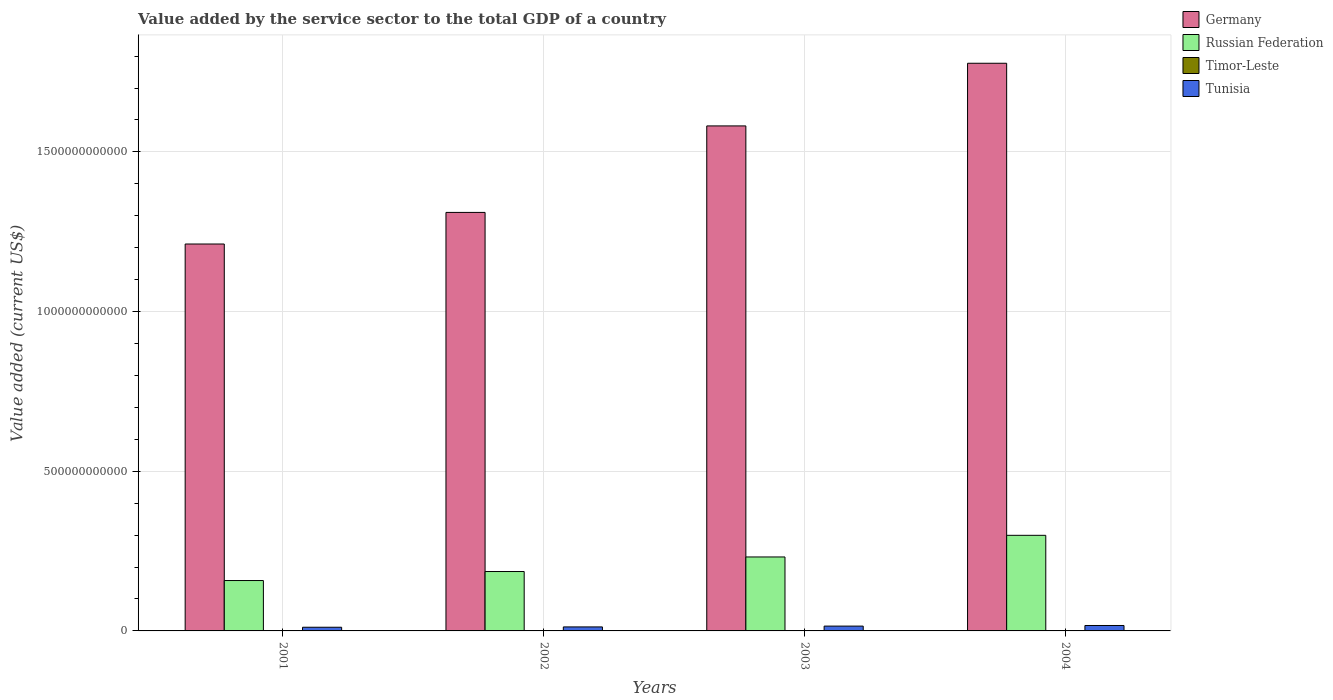How many different coloured bars are there?
Make the answer very short. 4. How many groups of bars are there?
Give a very brief answer. 4. Are the number of bars per tick equal to the number of legend labels?
Provide a succinct answer. Yes. How many bars are there on the 2nd tick from the right?
Make the answer very short. 4. In how many cases, is the number of bars for a given year not equal to the number of legend labels?
Provide a short and direct response. 0. What is the value added by the service sector to the total GDP in Russian Federation in 2001?
Provide a short and direct response. 1.58e+11. Across all years, what is the maximum value added by the service sector to the total GDP in Timor-Leste?
Keep it short and to the point. 2.78e+08. Across all years, what is the minimum value added by the service sector to the total GDP in Germany?
Offer a terse response. 1.21e+12. In which year was the value added by the service sector to the total GDP in Tunisia maximum?
Your answer should be compact. 2004. In which year was the value added by the service sector to the total GDP in Tunisia minimum?
Provide a succinct answer. 2001. What is the total value added by the service sector to the total GDP in Timor-Leste in the graph?
Offer a very short reply. 1.08e+09. What is the difference between the value added by the service sector to the total GDP in Tunisia in 2001 and that in 2002?
Provide a short and direct response. -9.86e+08. What is the difference between the value added by the service sector to the total GDP in Germany in 2003 and the value added by the service sector to the total GDP in Tunisia in 2004?
Your response must be concise. 1.56e+12. What is the average value added by the service sector to the total GDP in Tunisia per year?
Keep it short and to the point. 1.40e+1. In the year 2001, what is the difference between the value added by the service sector to the total GDP in Russian Federation and value added by the service sector to the total GDP in Timor-Leste?
Give a very brief answer. 1.58e+11. In how many years, is the value added by the service sector to the total GDP in Tunisia greater than 1000000000000 US$?
Make the answer very short. 0. What is the ratio of the value added by the service sector to the total GDP in Timor-Leste in 2003 to that in 2004?
Give a very brief answer. 0.97. What is the difference between the highest and the second highest value added by the service sector to the total GDP in Tunisia?
Ensure brevity in your answer.  1.94e+09. What is the difference between the highest and the lowest value added by the service sector to the total GDP in Tunisia?
Ensure brevity in your answer.  5.48e+09. In how many years, is the value added by the service sector to the total GDP in Timor-Leste greater than the average value added by the service sector to the total GDP in Timor-Leste taken over all years?
Ensure brevity in your answer.  2. Is the sum of the value added by the service sector to the total GDP in Russian Federation in 2002 and 2003 greater than the maximum value added by the service sector to the total GDP in Timor-Leste across all years?
Provide a short and direct response. Yes. What does the 4th bar from the left in 2004 represents?
Offer a very short reply. Tunisia. What does the 1st bar from the right in 2002 represents?
Offer a very short reply. Tunisia. How many bars are there?
Provide a short and direct response. 16. How many years are there in the graph?
Provide a succinct answer. 4. What is the difference between two consecutive major ticks on the Y-axis?
Give a very brief answer. 5.00e+11. Are the values on the major ticks of Y-axis written in scientific E-notation?
Keep it short and to the point. No. What is the title of the graph?
Your response must be concise. Value added by the service sector to the total GDP of a country. What is the label or title of the Y-axis?
Give a very brief answer. Value added (current US$). What is the Value added (current US$) in Germany in 2001?
Offer a terse response. 1.21e+12. What is the Value added (current US$) of Russian Federation in 2001?
Provide a short and direct response. 1.58e+11. What is the Value added (current US$) of Timor-Leste in 2001?
Provide a short and direct response. 2.78e+08. What is the Value added (current US$) of Tunisia in 2001?
Keep it short and to the point. 1.15e+1. What is the Value added (current US$) of Germany in 2002?
Keep it short and to the point. 1.31e+12. What is the Value added (current US$) of Russian Federation in 2002?
Ensure brevity in your answer.  1.86e+11. What is the Value added (current US$) of Timor-Leste in 2002?
Give a very brief answer. 2.60e+08. What is the Value added (current US$) of Tunisia in 2002?
Offer a very short reply. 1.25e+1. What is the Value added (current US$) of Germany in 2003?
Offer a terse response. 1.58e+12. What is the Value added (current US$) of Russian Federation in 2003?
Make the answer very short. 2.32e+11. What is the Value added (current US$) of Timor-Leste in 2003?
Provide a succinct answer. 2.65e+08. What is the Value added (current US$) of Tunisia in 2003?
Your response must be concise. 1.51e+1. What is the Value added (current US$) in Germany in 2004?
Make the answer very short. 1.78e+12. What is the Value added (current US$) of Russian Federation in 2004?
Offer a terse response. 2.99e+11. What is the Value added (current US$) in Timor-Leste in 2004?
Your answer should be compact. 2.72e+08. What is the Value added (current US$) in Tunisia in 2004?
Ensure brevity in your answer.  1.70e+1. Across all years, what is the maximum Value added (current US$) of Germany?
Provide a short and direct response. 1.78e+12. Across all years, what is the maximum Value added (current US$) in Russian Federation?
Your answer should be compact. 2.99e+11. Across all years, what is the maximum Value added (current US$) of Timor-Leste?
Your answer should be compact. 2.78e+08. Across all years, what is the maximum Value added (current US$) in Tunisia?
Provide a short and direct response. 1.70e+1. Across all years, what is the minimum Value added (current US$) in Germany?
Your answer should be very brief. 1.21e+12. Across all years, what is the minimum Value added (current US$) of Russian Federation?
Keep it short and to the point. 1.58e+11. Across all years, what is the minimum Value added (current US$) of Timor-Leste?
Provide a short and direct response. 2.60e+08. Across all years, what is the minimum Value added (current US$) of Tunisia?
Your response must be concise. 1.15e+1. What is the total Value added (current US$) in Germany in the graph?
Your response must be concise. 5.88e+12. What is the total Value added (current US$) in Russian Federation in the graph?
Your answer should be very brief. 8.75e+11. What is the total Value added (current US$) of Timor-Leste in the graph?
Ensure brevity in your answer.  1.08e+09. What is the total Value added (current US$) in Tunisia in the graph?
Your answer should be very brief. 5.62e+1. What is the difference between the Value added (current US$) of Germany in 2001 and that in 2002?
Provide a succinct answer. -9.89e+1. What is the difference between the Value added (current US$) in Russian Federation in 2001 and that in 2002?
Provide a short and direct response. -2.82e+1. What is the difference between the Value added (current US$) of Timor-Leste in 2001 and that in 2002?
Provide a succinct answer. 1.80e+07. What is the difference between the Value added (current US$) of Tunisia in 2001 and that in 2002?
Make the answer very short. -9.86e+08. What is the difference between the Value added (current US$) in Germany in 2001 and that in 2003?
Offer a terse response. -3.70e+11. What is the difference between the Value added (current US$) in Russian Federation in 2001 and that in 2003?
Offer a terse response. -7.38e+1. What is the difference between the Value added (current US$) of Timor-Leste in 2001 and that in 2003?
Give a very brief answer. 1.30e+07. What is the difference between the Value added (current US$) in Tunisia in 2001 and that in 2003?
Your response must be concise. -3.55e+09. What is the difference between the Value added (current US$) in Germany in 2001 and that in 2004?
Your answer should be compact. -5.66e+11. What is the difference between the Value added (current US$) in Russian Federation in 2001 and that in 2004?
Offer a very short reply. -1.42e+11. What is the difference between the Value added (current US$) in Timor-Leste in 2001 and that in 2004?
Make the answer very short. 6.00e+06. What is the difference between the Value added (current US$) of Tunisia in 2001 and that in 2004?
Your answer should be very brief. -5.48e+09. What is the difference between the Value added (current US$) of Germany in 2002 and that in 2003?
Give a very brief answer. -2.71e+11. What is the difference between the Value added (current US$) in Russian Federation in 2002 and that in 2003?
Your answer should be very brief. -4.56e+1. What is the difference between the Value added (current US$) of Timor-Leste in 2002 and that in 2003?
Keep it short and to the point. -5.00e+06. What is the difference between the Value added (current US$) of Tunisia in 2002 and that in 2003?
Make the answer very short. -2.56e+09. What is the difference between the Value added (current US$) of Germany in 2002 and that in 2004?
Provide a succinct answer. -4.67e+11. What is the difference between the Value added (current US$) of Russian Federation in 2002 and that in 2004?
Offer a very short reply. -1.13e+11. What is the difference between the Value added (current US$) in Timor-Leste in 2002 and that in 2004?
Your answer should be very brief. -1.20e+07. What is the difference between the Value added (current US$) in Tunisia in 2002 and that in 2004?
Give a very brief answer. -4.50e+09. What is the difference between the Value added (current US$) in Germany in 2003 and that in 2004?
Keep it short and to the point. -1.96e+11. What is the difference between the Value added (current US$) of Russian Federation in 2003 and that in 2004?
Your answer should be very brief. -6.78e+1. What is the difference between the Value added (current US$) in Timor-Leste in 2003 and that in 2004?
Offer a terse response. -7.00e+06. What is the difference between the Value added (current US$) in Tunisia in 2003 and that in 2004?
Ensure brevity in your answer.  -1.94e+09. What is the difference between the Value added (current US$) of Germany in 2001 and the Value added (current US$) of Russian Federation in 2002?
Provide a short and direct response. 1.03e+12. What is the difference between the Value added (current US$) in Germany in 2001 and the Value added (current US$) in Timor-Leste in 2002?
Ensure brevity in your answer.  1.21e+12. What is the difference between the Value added (current US$) in Germany in 2001 and the Value added (current US$) in Tunisia in 2002?
Offer a very short reply. 1.20e+12. What is the difference between the Value added (current US$) of Russian Federation in 2001 and the Value added (current US$) of Timor-Leste in 2002?
Make the answer very short. 1.58e+11. What is the difference between the Value added (current US$) of Russian Federation in 2001 and the Value added (current US$) of Tunisia in 2002?
Offer a terse response. 1.45e+11. What is the difference between the Value added (current US$) in Timor-Leste in 2001 and the Value added (current US$) in Tunisia in 2002?
Your answer should be very brief. -1.22e+1. What is the difference between the Value added (current US$) of Germany in 2001 and the Value added (current US$) of Russian Federation in 2003?
Offer a terse response. 9.80e+11. What is the difference between the Value added (current US$) in Germany in 2001 and the Value added (current US$) in Timor-Leste in 2003?
Your response must be concise. 1.21e+12. What is the difference between the Value added (current US$) of Germany in 2001 and the Value added (current US$) of Tunisia in 2003?
Your answer should be compact. 1.20e+12. What is the difference between the Value added (current US$) in Russian Federation in 2001 and the Value added (current US$) in Timor-Leste in 2003?
Your response must be concise. 1.58e+11. What is the difference between the Value added (current US$) in Russian Federation in 2001 and the Value added (current US$) in Tunisia in 2003?
Provide a succinct answer. 1.43e+11. What is the difference between the Value added (current US$) of Timor-Leste in 2001 and the Value added (current US$) of Tunisia in 2003?
Offer a very short reply. -1.48e+1. What is the difference between the Value added (current US$) in Germany in 2001 and the Value added (current US$) in Russian Federation in 2004?
Give a very brief answer. 9.12e+11. What is the difference between the Value added (current US$) in Germany in 2001 and the Value added (current US$) in Timor-Leste in 2004?
Your answer should be very brief. 1.21e+12. What is the difference between the Value added (current US$) in Germany in 2001 and the Value added (current US$) in Tunisia in 2004?
Offer a very short reply. 1.19e+12. What is the difference between the Value added (current US$) in Russian Federation in 2001 and the Value added (current US$) in Timor-Leste in 2004?
Give a very brief answer. 1.58e+11. What is the difference between the Value added (current US$) in Russian Federation in 2001 and the Value added (current US$) in Tunisia in 2004?
Make the answer very short. 1.41e+11. What is the difference between the Value added (current US$) of Timor-Leste in 2001 and the Value added (current US$) of Tunisia in 2004?
Your answer should be compact. -1.67e+1. What is the difference between the Value added (current US$) in Germany in 2002 and the Value added (current US$) in Russian Federation in 2003?
Your answer should be compact. 1.08e+12. What is the difference between the Value added (current US$) of Germany in 2002 and the Value added (current US$) of Timor-Leste in 2003?
Your response must be concise. 1.31e+12. What is the difference between the Value added (current US$) of Germany in 2002 and the Value added (current US$) of Tunisia in 2003?
Offer a very short reply. 1.30e+12. What is the difference between the Value added (current US$) of Russian Federation in 2002 and the Value added (current US$) of Timor-Leste in 2003?
Give a very brief answer. 1.86e+11. What is the difference between the Value added (current US$) of Russian Federation in 2002 and the Value added (current US$) of Tunisia in 2003?
Offer a terse response. 1.71e+11. What is the difference between the Value added (current US$) of Timor-Leste in 2002 and the Value added (current US$) of Tunisia in 2003?
Offer a very short reply. -1.48e+1. What is the difference between the Value added (current US$) in Germany in 2002 and the Value added (current US$) in Russian Federation in 2004?
Offer a very short reply. 1.01e+12. What is the difference between the Value added (current US$) in Germany in 2002 and the Value added (current US$) in Timor-Leste in 2004?
Offer a very short reply. 1.31e+12. What is the difference between the Value added (current US$) in Germany in 2002 and the Value added (current US$) in Tunisia in 2004?
Offer a very short reply. 1.29e+12. What is the difference between the Value added (current US$) in Russian Federation in 2002 and the Value added (current US$) in Timor-Leste in 2004?
Keep it short and to the point. 1.86e+11. What is the difference between the Value added (current US$) in Russian Federation in 2002 and the Value added (current US$) in Tunisia in 2004?
Ensure brevity in your answer.  1.69e+11. What is the difference between the Value added (current US$) of Timor-Leste in 2002 and the Value added (current US$) of Tunisia in 2004?
Provide a short and direct response. -1.68e+1. What is the difference between the Value added (current US$) of Germany in 2003 and the Value added (current US$) of Russian Federation in 2004?
Ensure brevity in your answer.  1.28e+12. What is the difference between the Value added (current US$) in Germany in 2003 and the Value added (current US$) in Timor-Leste in 2004?
Your response must be concise. 1.58e+12. What is the difference between the Value added (current US$) of Germany in 2003 and the Value added (current US$) of Tunisia in 2004?
Offer a very short reply. 1.56e+12. What is the difference between the Value added (current US$) in Russian Federation in 2003 and the Value added (current US$) in Timor-Leste in 2004?
Offer a terse response. 2.31e+11. What is the difference between the Value added (current US$) of Russian Federation in 2003 and the Value added (current US$) of Tunisia in 2004?
Provide a succinct answer. 2.15e+11. What is the difference between the Value added (current US$) of Timor-Leste in 2003 and the Value added (current US$) of Tunisia in 2004?
Offer a terse response. -1.68e+1. What is the average Value added (current US$) of Germany per year?
Offer a very short reply. 1.47e+12. What is the average Value added (current US$) of Russian Federation per year?
Your answer should be compact. 2.19e+11. What is the average Value added (current US$) in Timor-Leste per year?
Offer a very short reply. 2.69e+08. What is the average Value added (current US$) of Tunisia per year?
Your answer should be compact. 1.40e+1. In the year 2001, what is the difference between the Value added (current US$) in Germany and Value added (current US$) in Russian Federation?
Make the answer very short. 1.05e+12. In the year 2001, what is the difference between the Value added (current US$) in Germany and Value added (current US$) in Timor-Leste?
Make the answer very short. 1.21e+12. In the year 2001, what is the difference between the Value added (current US$) in Germany and Value added (current US$) in Tunisia?
Your answer should be very brief. 1.20e+12. In the year 2001, what is the difference between the Value added (current US$) of Russian Federation and Value added (current US$) of Timor-Leste?
Give a very brief answer. 1.58e+11. In the year 2001, what is the difference between the Value added (current US$) in Russian Federation and Value added (current US$) in Tunisia?
Offer a very short reply. 1.46e+11. In the year 2001, what is the difference between the Value added (current US$) in Timor-Leste and Value added (current US$) in Tunisia?
Offer a terse response. -1.13e+1. In the year 2002, what is the difference between the Value added (current US$) in Germany and Value added (current US$) in Russian Federation?
Make the answer very short. 1.12e+12. In the year 2002, what is the difference between the Value added (current US$) in Germany and Value added (current US$) in Timor-Leste?
Give a very brief answer. 1.31e+12. In the year 2002, what is the difference between the Value added (current US$) of Germany and Value added (current US$) of Tunisia?
Make the answer very short. 1.30e+12. In the year 2002, what is the difference between the Value added (current US$) in Russian Federation and Value added (current US$) in Timor-Leste?
Your response must be concise. 1.86e+11. In the year 2002, what is the difference between the Value added (current US$) of Russian Federation and Value added (current US$) of Tunisia?
Your answer should be compact. 1.73e+11. In the year 2002, what is the difference between the Value added (current US$) of Timor-Leste and Value added (current US$) of Tunisia?
Provide a succinct answer. -1.23e+1. In the year 2003, what is the difference between the Value added (current US$) of Germany and Value added (current US$) of Russian Federation?
Make the answer very short. 1.35e+12. In the year 2003, what is the difference between the Value added (current US$) of Germany and Value added (current US$) of Timor-Leste?
Your answer should be very brief. 1.58e+12. In the year 2003, what is the difference between the Value added (current US$) in Germany and Value added (current US$) in Tunisia?
Give a very brief answer. 1.57e+12. In the year 2003, what is the difference between the Value added (current US$) in Russian Federation and Value added (current US$) in Timor-Leste?
Make the answer very short. 2.31e+11. In the year 2003, what is the difference between the Value added (current US$) in Russian Federation and Value added (current US$) in Tunisia?
Make the answer very short. 2.17e+11. In the year 2003, what is the difference between the Value added (current US$) of Timor-Leste and Value added (current US$) of Tunisia?
Your answer should be very brief. -1.48e+1. In the year 2004, what is the difference between the Value added (current US$) of Germany and Value added (current US$) of Russian Federation?
Your answer should be very brief. 1.48e+12. In the year 2004, what is the difference between the Value added (current US$) in Germany and Value added (current US$) in Timor-Leste?
Keep it short and to the point. 1.78e+12. In the year 2004, what is the difference between the Value added (current US$) in Germany and Value added (current US$) in Tunisia?
Offer a very short reply. 1.76e+12. In the year 2004, what is the difference between the Value added (current US$) of Russian Federation and Value added (current US$) of Timor-Leste?
Your response must be concise. 2.99e+11. In the year 2004, what is the difference between the Value added (current US$) of Russian Federation and Value added (current US$) of Tunisia?
Provide a succinct answer. 2.82e+11. In the year 2004, what is the difference between the Value added (current US$) in Timor-Leste and Value added (current US$) in Tunisia?
Provide a short and direct response. -1.67e+1. What is the ratio of the Value added (current US$) of Germany in 2001 to that in 2002?
Offer a very short reply. 0.92. What is the ratio of the Value added (current US$) in Russian Federation in 2001 to that in 2002?
Offer a very short reply. 0.85. What is the ratio of the Value added (current US$) in Timor-Leste in 2001 to that in 2002?
Offer a terse response. 1.07. What is the ratio of the Value added (current US$) in Tunisia in 2001 to that in 2002?
Provide a short and direct response. 0.92. What is the ratio of the Value added (current US$) in Germany in 2001 to that in 2003?
Offer a terse response. 0.77. What is the ratio of the Value added (current US$) of Russian Federation in 2001 to that in 2003?
Provide a succinct answer. 0.68. What is the ratio of the Value added (current US$) of Timor-Leste in 2001 to that in 2003?
Provide a short and direct response. 1.05. What is the ratio of the Value added (current US$) in Tunisia in 2001 to that in 2003?
Your response must be concise. 0.77. What is the ratio of the Value added (current US$) of Germany in 2001 to that in 2004?
Provide a short and direct response. 0.68. What is the ratio of the Value added (current US$) of Russian Federation in 2001 to that in 2004?
Offer a very short reply. 0.53. What is the ratio of the Value added (current US$) of Timor-Leste in 2001 to that in 2004?
Make the answer very short. 1.02. What is the ratio of the Value added (current US$) in Tunisia in 2001 to that in 2004?
Make the answer very short. 0.68. What is the ratio of the Value added (current US$) in Germany in 2002 to that in 2003?
Provide a succinct answer. 0.83. What is the ratio of the Value added (current US$) of Russian Federation in 2002 to that in 2003?
Ensure brevity in your answer.  0.8. What is the ratio of the Value added (current US$) in Timor-Leste in 2002 to that in 2003?
Offer a terse response. 0.98. What is the ratio of the Value added (current US$) of Tunisia in 2002 to that in 2003?
Offer a terse response. 0.83. What is the ratio of the Value added (current US$) in Germany in 2002 to that in 2004?
Give a very brief answer. 0.74. What is the ratio of the Value added (current US$) of Russian Federation in 2002 to that in 2004?
Make the answer very short. 0.62. What is the ratio of the Value added (current US$) in Timor-Leste in 2002 to that in 2004?
Your response must be concise. 0.96. What is the ratio of the Value added (current US$) of Tunisia in 2002 to that in 2004?
Ensure brevity in your answer.  0.74. What is the ratio of the Value added (current US$) in Germany in 2003 to that in 2004?
Offer a very short reply. 0.89. What is the ratio of the Value added (current US$) in Russian Federation in 2003 to that in 2004?
Keep it short and to the point. 0.77. What is the ratio of the Value added (current US$) of Timor-Leste in 2003 to that in 2004?
Ensure brevity in your answer.  0.97. What is the ratio of the Value added (current US$) of Tunisia in 2003 to that in 2004?
Make the answer very short. 0.89. What is the difference between the highest and the second highest Value added (current US$) in Germany?
Offer a very short reply. 1.96e+11. What is the difference between the highest and the second highest Value added (current US$) of Russian Federation?
Keep it short and to the point. 6.78e+1. What is the difference between the highest and the second highest Value added (current US$) in Tunisia?
Ensure brevity in your answer.  1.94e+09. What is the difference between the highest and the lowest Value added (current US$) in Germany?
Provide a succinct answer. 5.66e+11. What is the difference between the highest and the lowest Value added (current US$) of Russian Federation?
Your response must be concise. 1.42e+11. What is the difference between the highest and the lowest Value added (current US$) in Timor-Leste?
Make the answer very short. 1.80e+07. What is the difference between the highest and the lowest Value added (current US$) of Tunisia?
Your answer should be compact. 5.48e+09. 